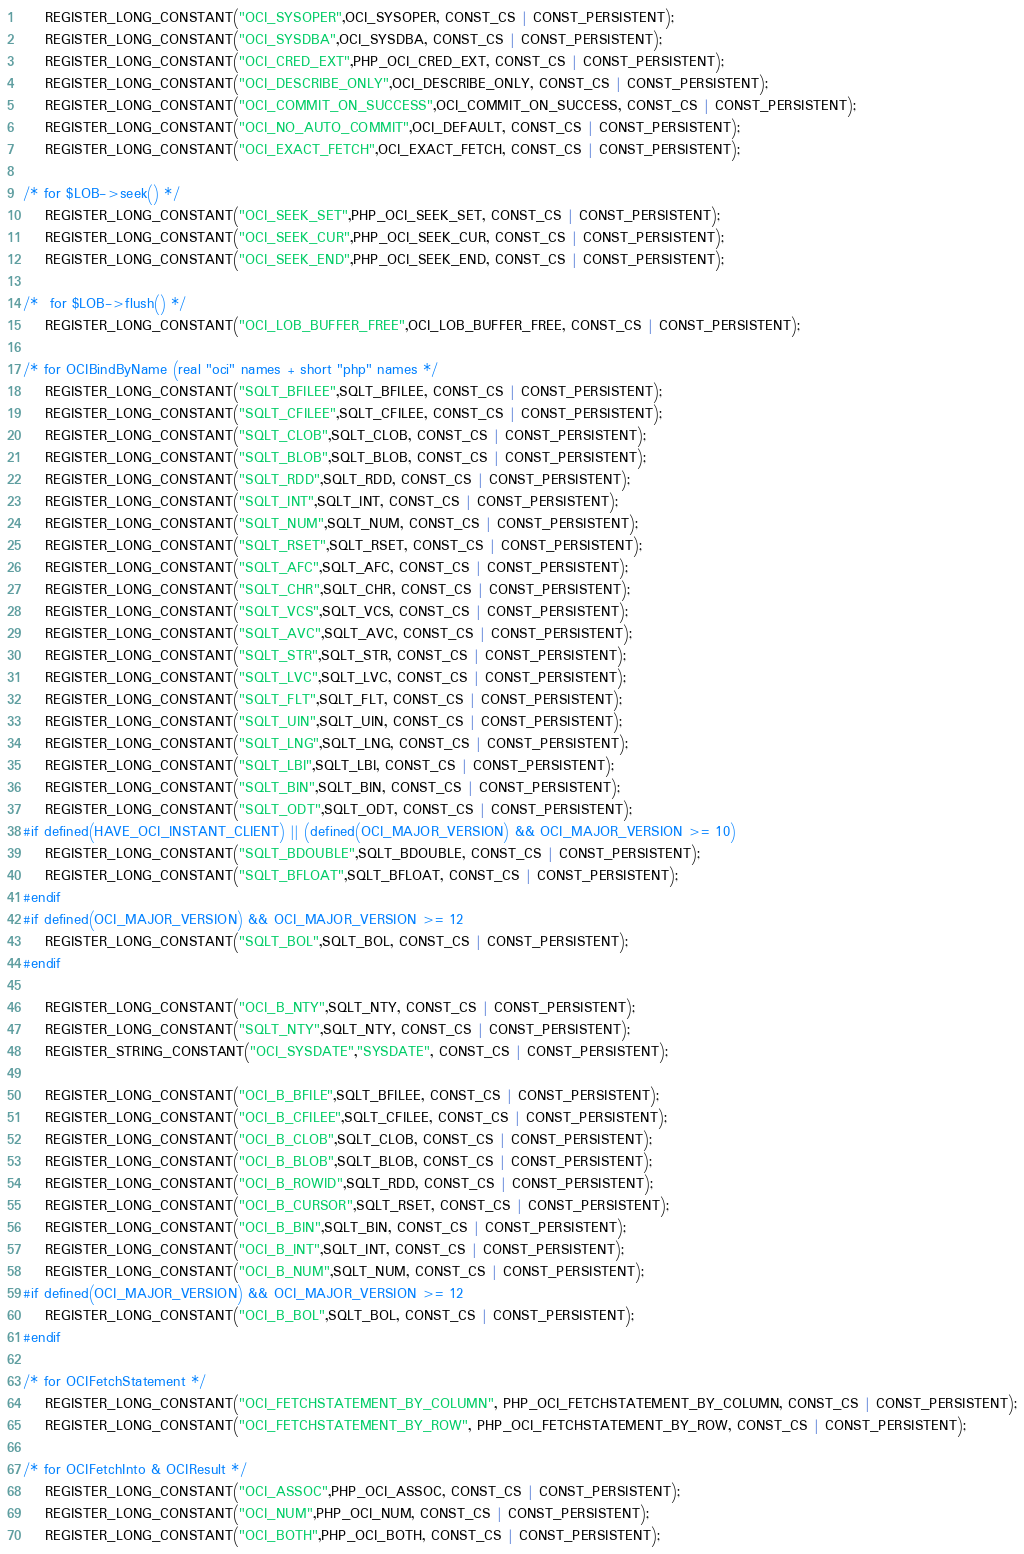<code> <loc_0><loc_0><loc_500><loc_500><_C_>	REGISTER_LONG_CONSTANT("OCI_SYSOPER",OCI_SYSOPER, CONST_CS | CONST_PERSISTENT);
	REGISTER_LONG_CONSTANT("OCI_SYSDBA",OCI_SYSDBA, CONST_CS | CONST_PERSISTENT);
	REGISTER_LONG_CONSTANT("OCI_CRED_EXT",PHP_OCI_CRED_EXT, CONST_CS | CONST_PERSISTENT);
	REGISTER_LONG_CONSTANT("OCI_DESCRIBE_ONLY",OCI_DESCRIBE_ONLY, CONST_CS | CONST_PERSISTENT);
	REGISTER_LONG_CONSTANT("OCI_COMMIT_ON_SUCCESS",OCI_COMMIT_ON_SUCCESS, CONST_CS | CONST_PERSISTENT);
	REGISTER_LONG_CONSTANT("OCI_NO_AUTO_COMMIT",OCI_DEFAULT, CONST_CS | CONST_PERSISTENT);
	REGISTER_LONG_CONSTANT("OCI_EXACT_FETCH",OCI_EXACT_FETCH, CONST_CS | CONST_PERSISTENT);

/* for $LOB->seek() */
	REGISTER_LONG_CONSTANT("OCI_SEEK_SET",PHP_OCI_SEEK_SET, CONST_CS | CONST_PERSISTENT);
	REGISTER_LONG_CONSTANT("OCI_SEEK_CUR",PHP_OCI_SEEK_CUR, CONST_CS | CONST_PERSISTENT);
	REGISTER_LONG_CONSTANT("OCI_SEEK_END",PHP_OCI_SEEK_END, CONST_CS | CONST_PERSISTENT);

/*	for $LOB->flush() */
	REGISTER_LONG_CONSTANT("OCI_LOB_BUFFER_FREE",OCI_LOB_BUFFER_FREE, CONST_CS | CONST_PERSISTENT);

/* for OCIBindByName (real "oci" names + short "php" names */
	REGISTER_LONG_CONSTANT("SQLT_BFILEE",SQLT_BFILEE, CONST_CS | CONST_PERSISTENT);
	REGISTER_LONG_CONSTANT("SQLT_CFILEE",SQLT_CFILEE, CONST_CS | CONST_PERSISTENT);
	REGISTER_LONG_CONSTANT("SQLT_CLOB",SQLT_CLOB, CONST_CS | CONST_PERSISTENT);
	REGISTER_LONG_CONSTANT("SQLT_BLOB",SQLT_BLOB, CONST_CS | CONST_PERSISTENT);
	REGISTER_LONG_CONSTANT("SQLT_RDD",SQLT_RDD, CONST_CS | CONST_PERSISTENT);
	REGISTER_LONG_CONSTANT("SQLT_INT",SQLT_INT, CONST_CS | CONST_PERSISTENT);
	REGISTER_LONG_CONSTANT("SQLT_NUM",SQLT_NUM, CONST_CS | CONST_PERSISTENT);
	REGISTER_LONG_CONSTANT("SQLT_RSET",SQLT_RSET, CONST_CS | CONST_PERSISTENT);
	REGISTER_LONG_CONSTANT("SQLT_AFC",SQLT_AFC, CONST_CS | CONST_PERSISTENT);
	REGISTER_LONG_CONSTANT("SQLT_CHR",SQLT_CHR, CONST_CS | CONST_PERSISTENT);
	REGISTER_LONG_CONSTANT("SQLT_VCS",SQLT_VCS, CONST_CS | CONST_PERSISTENT);
	REGISTER_LONG_CONSTANT("SQLT_AVC",SQLT_AVC, CONST_CS | CONST_PERSISTENT);
	REGISTER_LONG_CONSTANT("SQLT_STR",SQLT_STR, CONST_CS | CONST_PERSISTENT);
	REGISTER_LONG_CONSTANT("SQLT_LVC",SQLT_LVC, CONST_CS | CONST_PERSISTENT);
	REGISTER_LONG_CONSTANT("SQLT_FLT",SQLT_FLT, CONST_CS | CONST_PERSISTENT);
	REGISTER_LONG_CONSTANT("SQLT_UIN",SQLT_UIN, CONST_CS | CONST_PERSISTENT);
	REGISTER_LONG_CONSTANT("SQLT_LNG",SQLT_LNG, CONST_CS | CONST_PERSISTENT);
	REGISTER_LONG_CONSTANT("SQLT_LBI",SQLT_LBI, CONST_CS | CONST_PERSISTENT);
	REGISTER_LONG_CONSTANT("SQLT_BIN",SQLT_BIN, CONST_CS | CONST_PERSISTENT);
	REGISTER_LONG_CONSTANT("SQLT_ODT",SQLT_ODT, CONST_CS | CONST_PERSISTENT);
#if defined(HAVE_OCI_INSTANT_CLIENT) || (defined(OCI_MAJOR_VERSION) && OCI_MAJOR_VERSION >= 10)
	REGISTER_LONG_CONSTANT("SQLT_BDOUBLE",SQLT_BDOUBLE, CONST_CS | CONST_PERSISTENT);
	REGISTER_LONG_CONSTANT("SQLT_BFLOAT",SQLT_BFLOAT, CONST_CS | CONST_PERSISTENT);
#endif
#if defined(OCI_MAJOR_VERSION) && OCI_MAJOR_VERSION >= 12
	REGISTER_LONG_CONSTANT("SQLT_BOL",SQLT_BOL, CONST_CS | CONST_PERSISTENT);
#endif

	REGISTER_LONG_CONSTANT("OCI_B_NTY",SQLT_NTY, CONST_CS | CONST_PERSISTENT);
	REGISTER_LONG_CONSTANT("SQLT_NTY",SQLT_NTY, CONST_CS | CONST_PERSISTENT);
	REGISTER_STRING_CONSTANT("OCI_SYSDATE","SYSDATE", CONST_CS | CONST_PERSISTENT);

	REGISTER_LONG_CONSTANT("OCI_B_BFILE",SQLT_BFILEE, CONST_CS | CONST_PERSISTENT);
	REGISTER_LONG_CONSTANT("OCI_B_CFILEE",SQLT_CFILEE, CONST_CS | CONST_PERSISTENT);
	REGISTER_LONG_CONSTANT("OCI_B_CLOB",SQLT_CLOB, CONST_CS | CONST_PERSISTENT);
	REGISTER_LONG_CONSTANT("OCI_B_BLOB",SQLT_BLOB, CONST_CS | CONST_PERSISTENT);
	REGISTER_LONG_CONSTANT("OCI_B_ROWID",SQLT_RDD, CONST_CS | CONST_PERSISTENT);
	REGISTER_LONG_CONSTANT("OCI_B_CURSOR",SQLT_RSET, CONST_CS | CONST_PERSISTENT);
	REGISTER_LONG_CONSTANT("OCI_B_BIN",SQLT_BIN, CONST_CS | CONST_PERSISTENT);
	REGISTER_LONG_CONSTANT("OCI_B_INT",SQLT_INT, CONST_CS | CONST_PERSISTENT);
	REGISTER_LONG_CONSTANT("OCI_B_NUM",SQLT_NUM, CONST_CS | CONST_PERSISTENT);
#if defined(OCI_MAJOR_VERSION) && OCI_MAJOR_VERSION >= 12
	REGISTER_LONG_CONSTANT("OCI_B_BOL",SQLT_BOL, CONST_CS | CONST_PERSISTENT);
#endif

/* for OCIFetchStatement */
	REGISTER_LONG_CONSTANT("OCI_FETCHSTATEMENT_BY_COLUMN", PHP_OCI_FETCHSTATEMENT_BY_COLUMN, CONST_CS | CONST_PERSISTENT);
	REGISTER_LONG_CONSTANT("OCI_FETCHSTATEMENT_BY_ROW", PHP_OCI_FETCHSTATEMENT_BY_ROW, CONST_CS | CONST_PERSISTENT);

/* for OCIFetchInto & OCIResult */
	REGISTER_LONG_CONSTANT("OCI_ASSOC",PHP_OCI_ASSOC, CONST_CS | CONST_PERSISTENT);
	REGISTER_LONG_CONSTANT("OCI_NUM",PHP_OCI_NUM, CONST_CS | CONST_PERSISTENT);
	REGISTER_LONG_CONSTANT("OCI_BOTH",PHP_OCI_BOTH, CONST_CS | CONST_PERSISTENT);</code> 